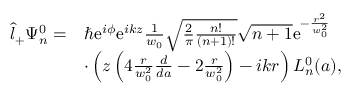Convert formula to latex. <formula><loc_0><loc_0><loc_500><loc_500>\begin{array} { r l } { \hat { l } _ { + } \Psi _ { n } ^ { 0 } = } & { \hbar { e } ^ { i \phi } e ^ { i k z } \frac { 1 } { w _ { 0 } } \sqrt { \frac { 2 } { \pi } \frac { n ! } { ( n + 1 ) ! } } \sqrt { n + 1 } e ^ { - \frac { r ^ { 2 } } { w _ { 0 } ^ { 2 } } } } \\ & { \cdot \left ( z \left ( 4 \frac { r } { w _ { 0 } ^ { 2 } } \frac { d } { d a } - 2 \frac { r } { w _ { 0 } ^ { 2 } } \right ) - i k r \right ) L _ { n } ^ { 0 } ( a ) , } \end{array}</formula> 